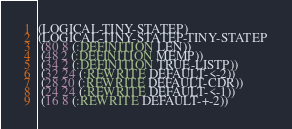Convert code to text. <code><loc_0><loc_0><loc_500><loc_500><_Lisp_>(LOGICAL-TINY-STATEP)
(LOGICAL-TINY-STATEP-TINY-STATEP
 (80 8 (:DEFINITION LEN))
 (48 2 (:DEFINITION MEMP))
 (34 2 (:DEFINITION TRUE-LISTP))
 (32 24 (:REWRITE DEFAULT-<-2))
 (28 20 (:REWRITE DEFAULT-CDR))
 (24 24 (:REWRITE DEFAULT-<-1))
 (16 8 (:REWRITE DEFAULT-+-2))</code> 